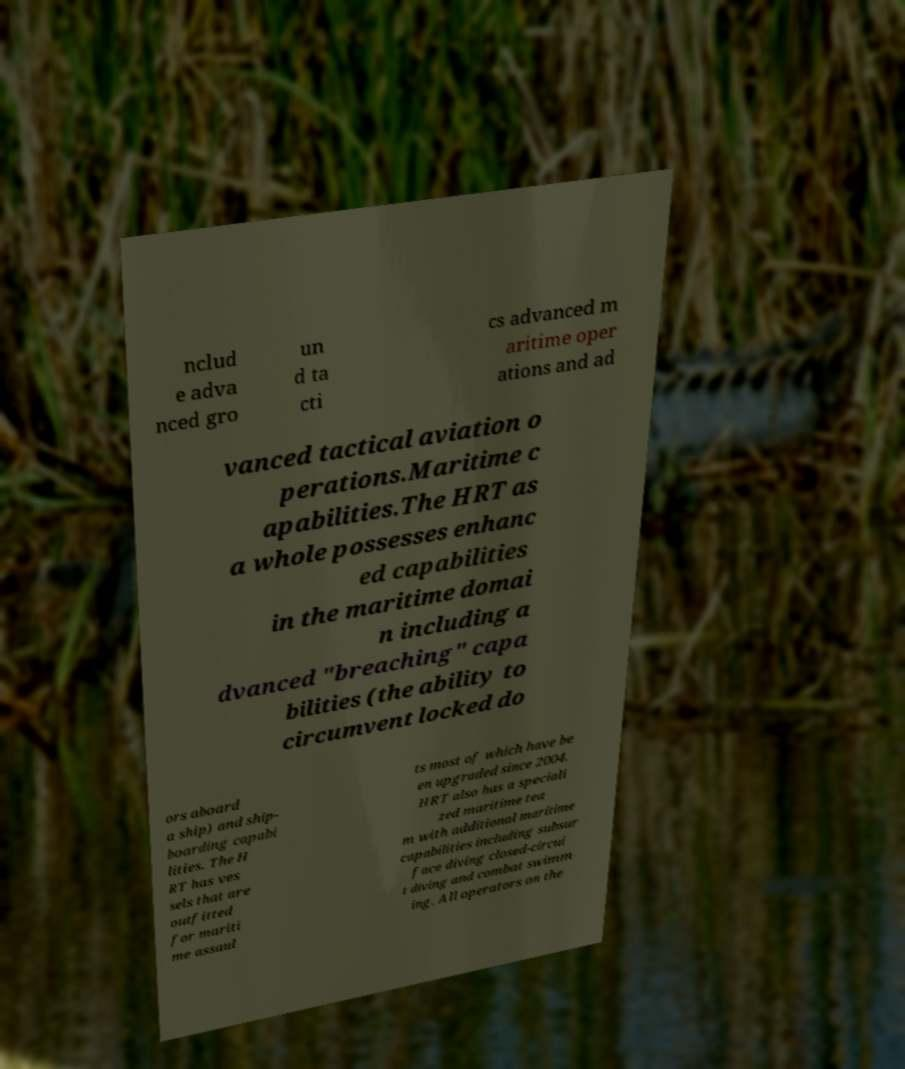There's text embedded in this image that I need extracted. Can you transcribe it verbatim? nclud e adva nced gro un d ta cti cs advanced m aritime oper ations and ad vanced tactical aviation o perations.Maritime c apabilities.The HRT as a whole possesses enhanc ed capabilities in the maritime domai n including a dvanced "breaching" capa bilities (the ability to circumvent locked do ors aboard a ship) and ship- boarding capabi lities. The H RT has ves sels that are outfitted for mariti me assaul ts most of which have be en upgraded since 2004. HRT also has a speciali zed maritime tea m with additional maritime capabilities including subsur face diving closed-circui t diving and combat swimm ing. All operators on the 